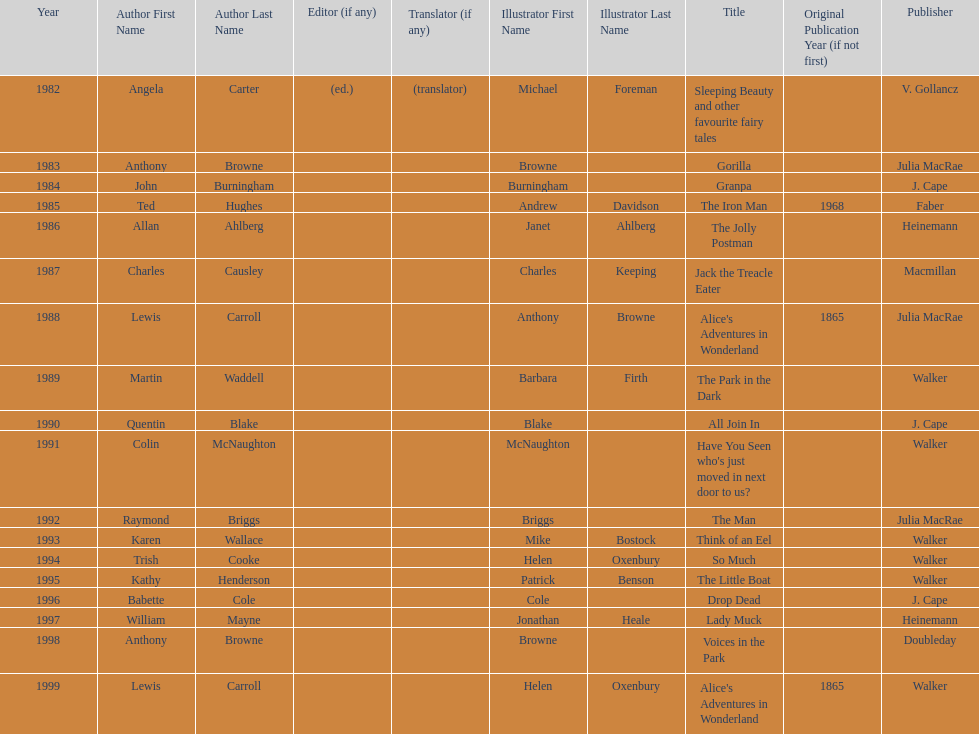What's the difference in years between angela carter's title and anthony browne's? 1. 